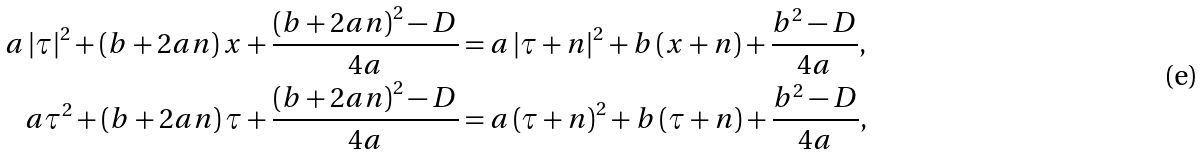<formula> <loc_0><loc_0><loc_500><loc_500>a \left | \tau \right | ^ { 2 } + \left ( b + 2 a n \right ) x + \frac { \left ( b + 2 a n \right ) ^ { 2 } - D } { 4 a } & = a \left | \tau + n \right | ^ { 2 } + b \left ( x + n \right ) + \frac { b ^ { 2 } - D } { 4 a } , \\ a \tau ^ { 2 } + \left ( b + 2 a n \right ) \tau + \frac { \left ( b + 2 a n \right ) ^ { 2 } - D } { 4 a } & = a \left ( \tau + n \right ) ^ { 2 } + b \left ( \tau + n \right ) + \frac { b ^ { 2 } - D } { 4 a } ,</formula> 